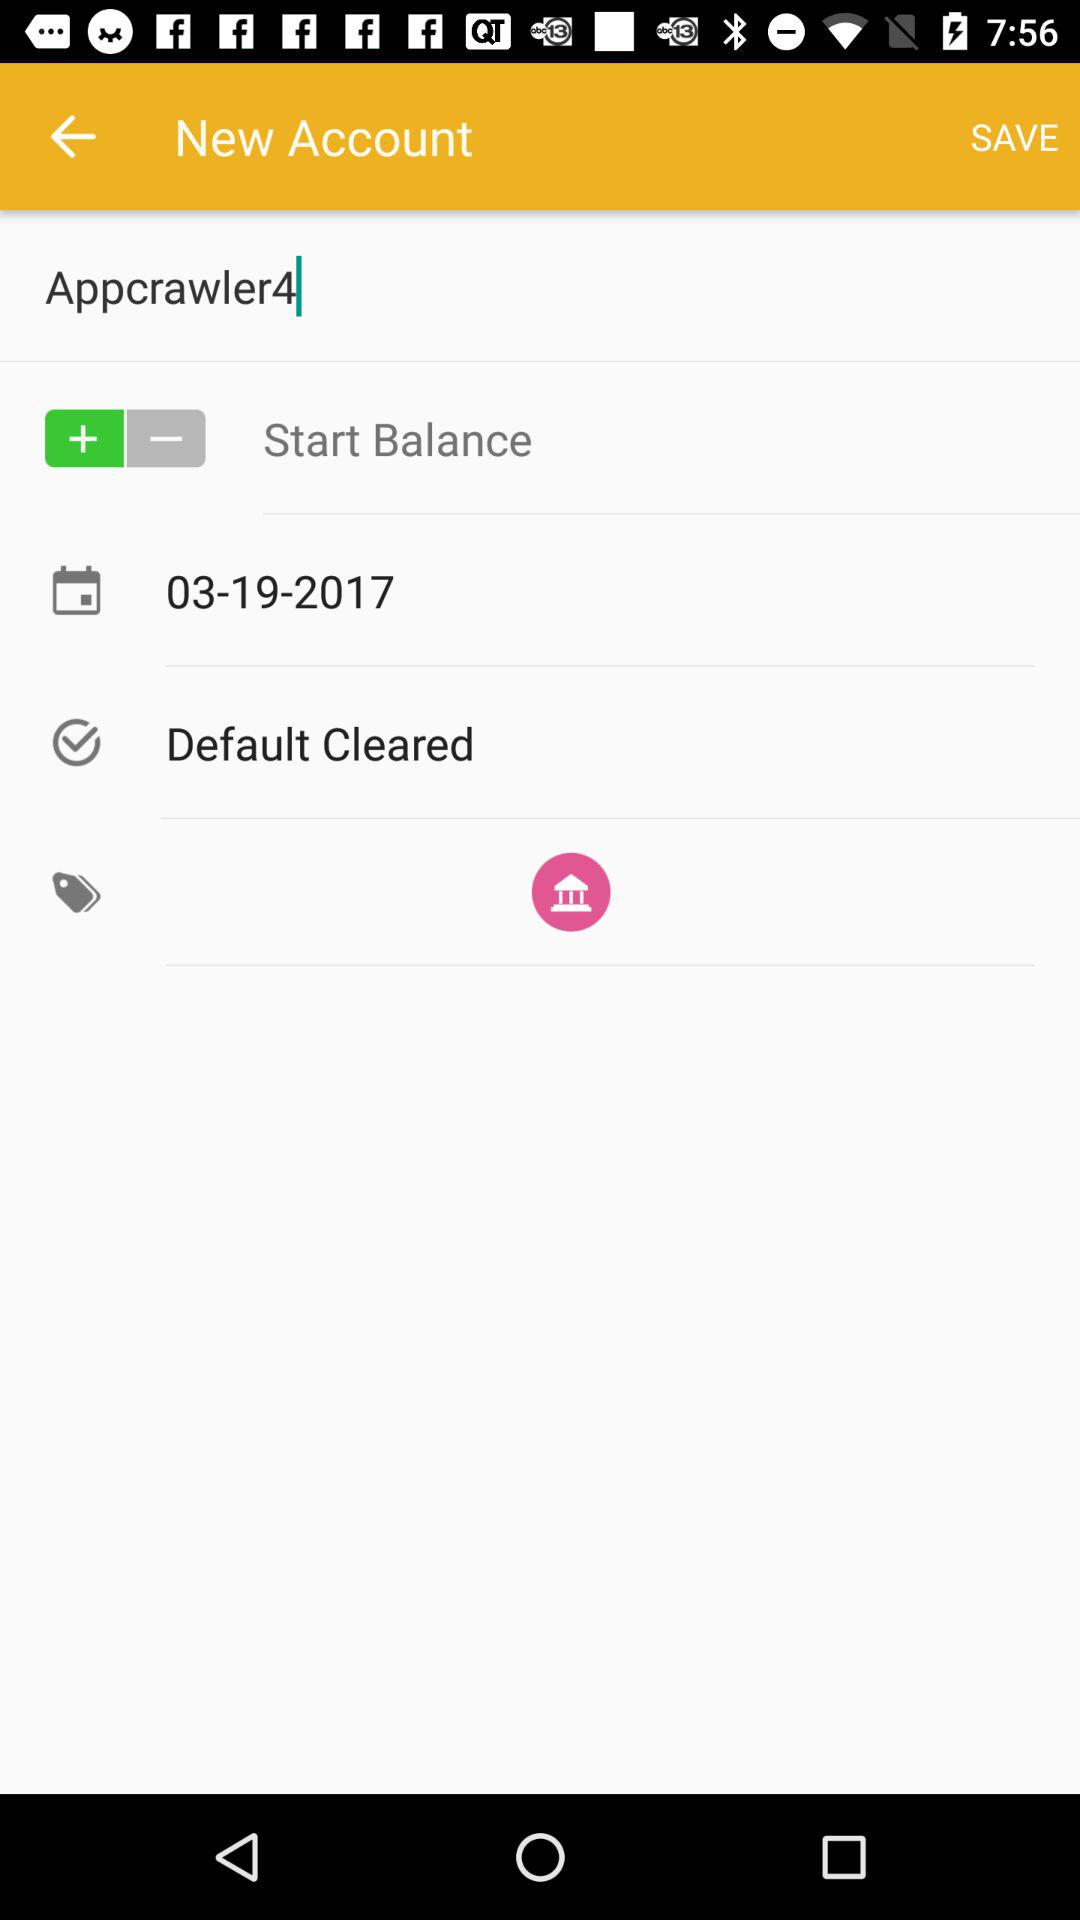What is the name of the user? The name of the user is Appcrawler4. 